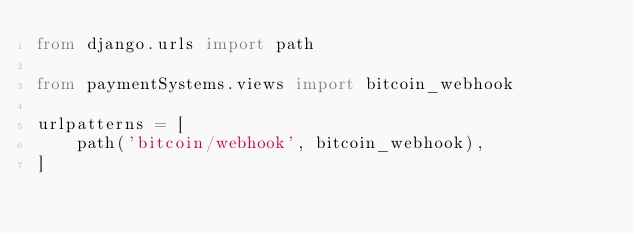<code> <loc_0><loc_0><loc_500><loc_500><_Python_>from django.urls import path

from paymentSystems.views import bitcoin_webhook

urlpatterns = [
    path('bitcoin/webhook', bitcoin_webhook),
]</code> 